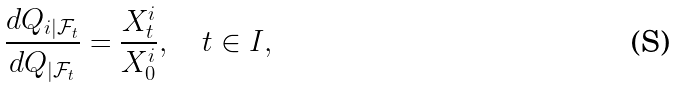Convert formula to latex. <formula><loc_0><loc_0><loc_500><loc_500>\frac { d Q _ { i | \mathcal { F } _ { t } } } { d Q _ { | \mathcal { F } _ { t } } } = \frac { X ^ { i } _ { t } } { X ^ { i } _ { 0 } } , \quad t \in I ,</formula> 